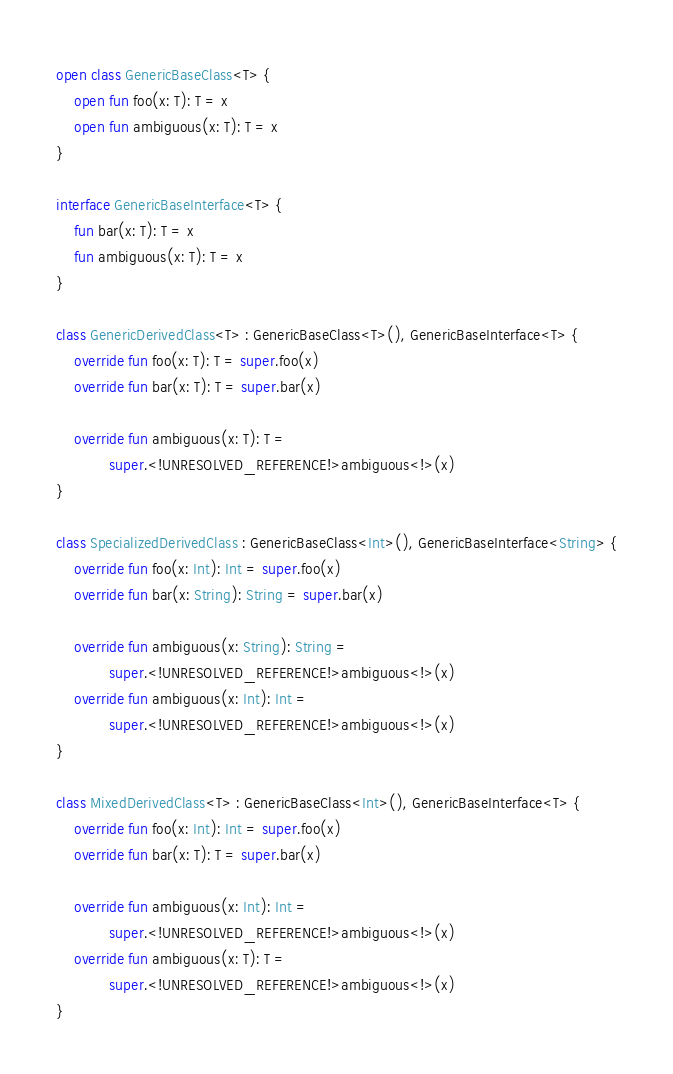Convert code to text. <code><loc_0><loc_0><loc_500><loc_500><_Kotlin_>open class GenericBaseClass<T> {
    open fun foo(x: T): T = x
    open fun ambiguous(x: T): T = x
}

interface GenericBaseInterface<T> {
    fun bar(x: T): T = x
    fun ambiguous(x: T): T = x
}

class GenericDerivedClass<T> : GenericBaseClass<T>(), GenericBaseInterface<T> {
    override fun foo(x: T): T = super.foo(x)
    override fun bar(x: T): T = super.bar(x)

    override fun ambiguous(x: T): T =
            super.<!UNRESOLVED_REFERENCE!>ambiguous<!>(x)
}

class SpecializedDerivedClass : GenericBaseClass<Int>(), GenericBaseInterface<String> {
    override fun foo(x: Int): Int = super.foo(x)
    override fun bar(x: String): String = super.bar(x)

    override fun ambiguous(x: String): String =
            super.<!UNRESOLVED_REFERENCE!>ambiguous<!>(x)
    override fun ambiguous(x: Int): Int =
            super.<!UNRESOLVED_REFERENCE!>ambiguous<!>(x)
}

class MixedDerivedClass<T> : GenericBaseClass<Int>(), GenericBaseInterface<T> {
    override fun foo(x: Int): Int = super.foo(x)
    override fun bar(x: T): T = super.bar(x)

    override fun ambiguous(x: Int): Int =
            super.<!UNRESOLVED_REFERENCE!>ambiguous<!>(x)
    override fun ambiguous(x: T): T =
            super.<!UNRESOLVED_REFERENCE!>ambiguous<!>(x)
}
</code> 